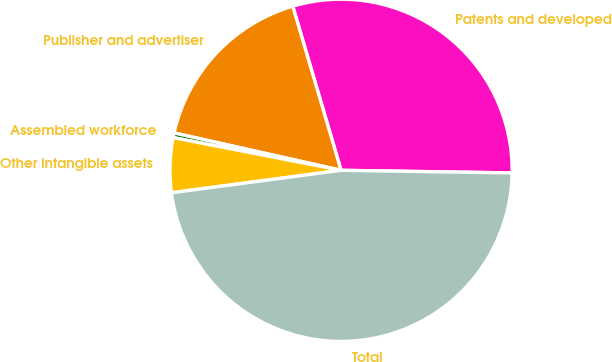Convert chart. <chart><loc_0><loc_0><loc_500><loc_500><pie_chart><fcel>Patents and developed<fcel>Publisher and advertiser<fcel>Assembled workforce<fcel>Other intangible assets<fcel>Total<nl><fcel>29.8%<fcel>16.94%<fcel>0.44%<fcel>5.16%<fcel>47.66%<nl></chart> 